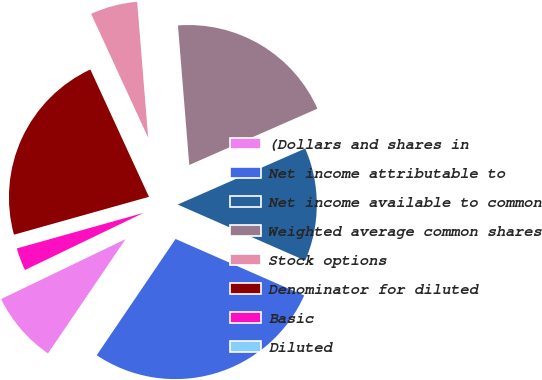Convert chart to OTSL. <chart><loc_0><loc_0><loc_500><loc_500><pie_chart><fcel>(Dollars and shares in<fcel>Net income attributable to<fcel>Net income available to common<fcel>Weighted average common shares<fcel>Stock options<fcel>Denominator for diluted<fcel>Basic<fcel>Diluted<nl><fcel>8.37%<fcel>27.9%<fcel>13.18%<fcel>19.7%<fcel>5.58%<fcel>22.49%<fcel>2.79%<fcel>0.0%<nl></chart> 